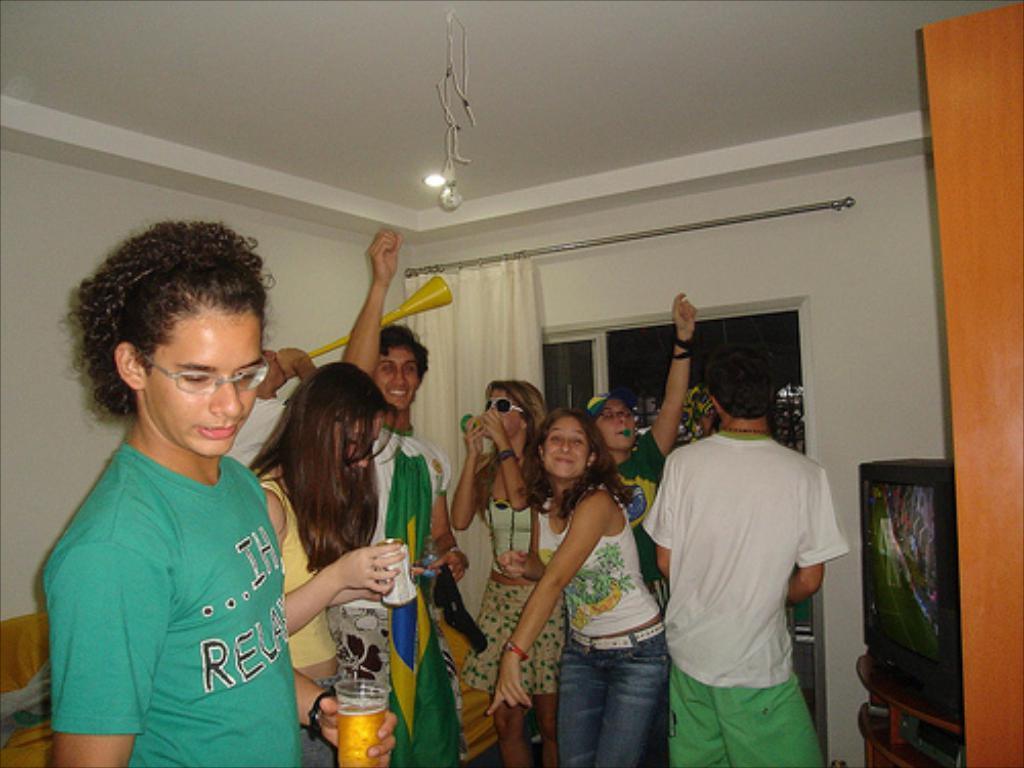Please provide a concise description of this image. In the picture there are a group of people partying in a room, on the right side there is a television and few people are holding glasses and drinks in their hand and some of them are dancing. In the background there is a wall and in front of the wall there is a curtain. 